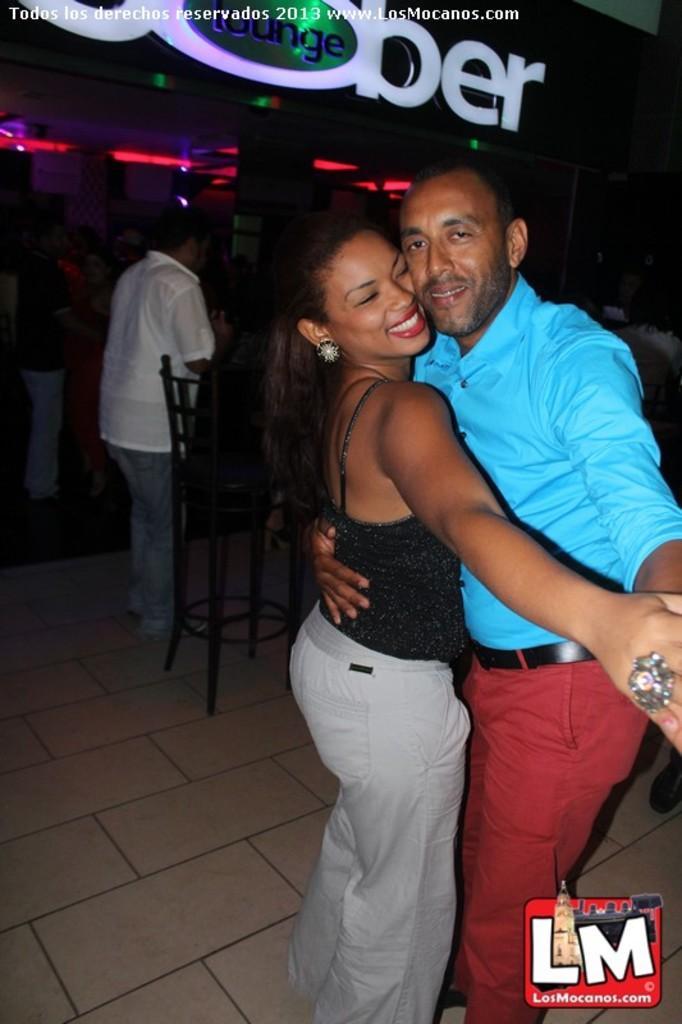How would you summarize this image in a sentence or two? In the foreground of the picture there is a couple dancing. At the bottom there is a logo. In the background there are chairs, people, text and lights. At the top there is text. 